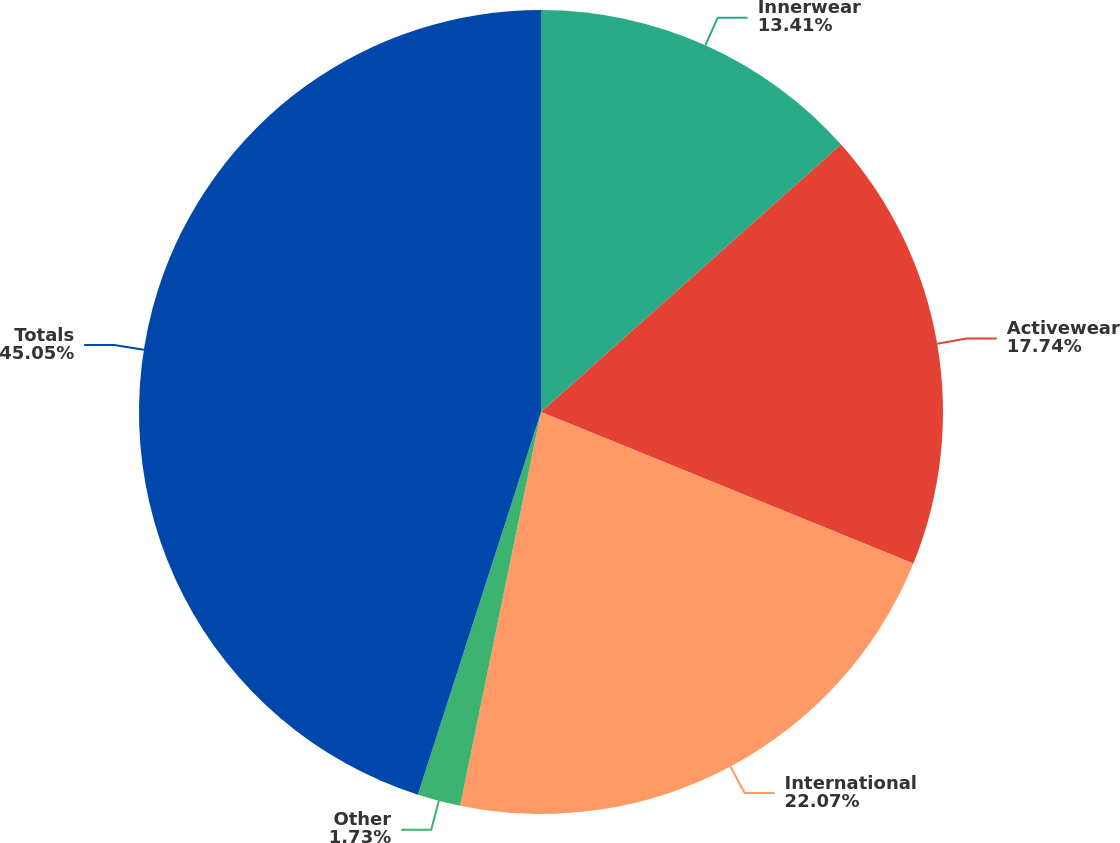Convert chart to OTSL. <chart><loc_0><loc_0><loc_500><loc_500><pie_chart><fcel>Innerwear<fcel>Activewear<fcel>International<fcel>Other<fcel>Totals<nl><fcel>13.41%<fcel>17.74%<fcel>22.07%<fcel>1.73%<fcel>45.04%<nl></chart> 